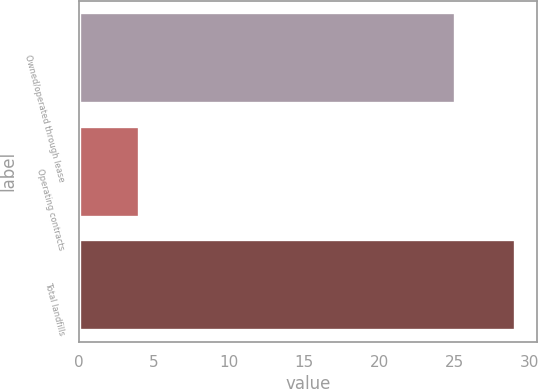Convert chart to OTSL. <chart><loc_0><loc_0><loc_500><loc_500><bar_chart><fcel>Owned/operated through lease<fcel>Operating contracts<fcel>Total landfills<nl><fcel>25<fcel>4<fcel>29<nl></chart> 